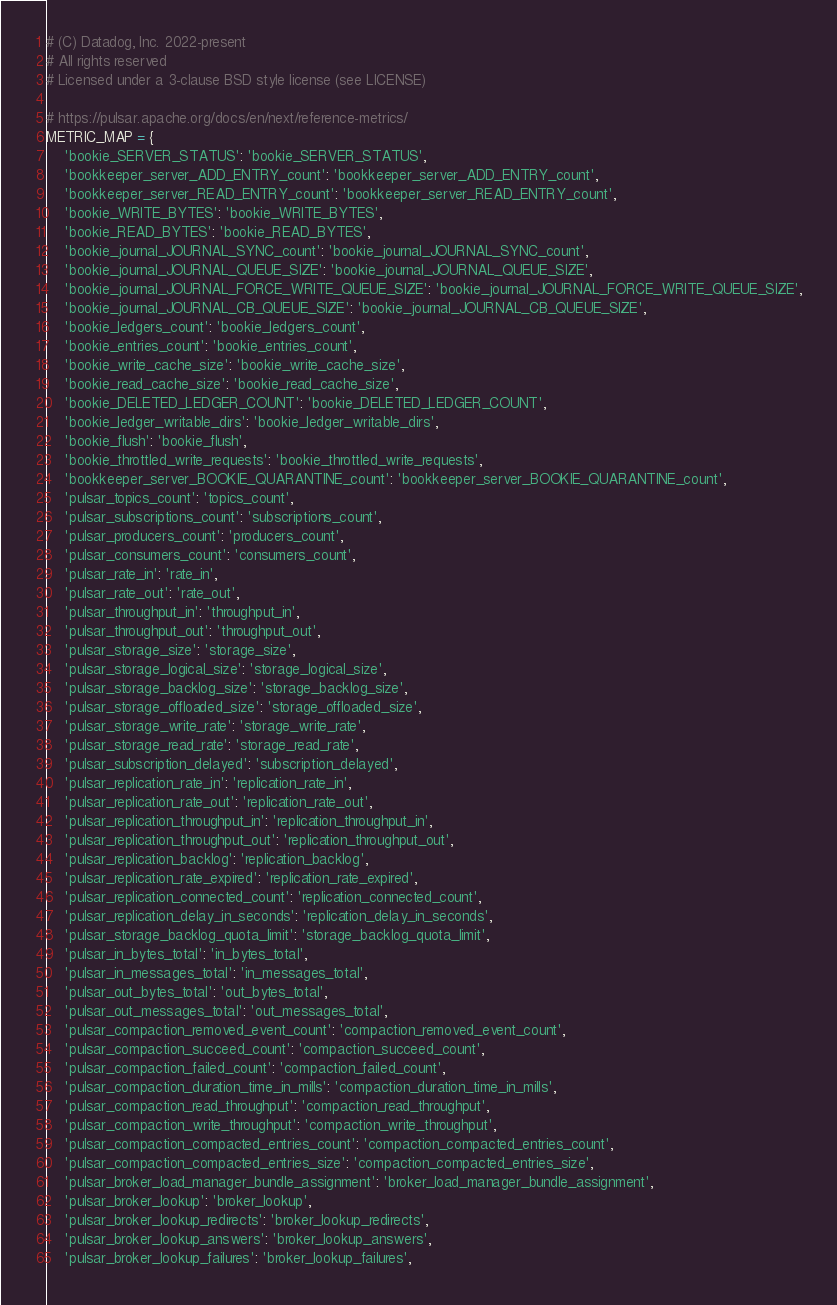<code> <loc_0><loc_0><loc_500><loc_500><_Python_># (C) Datadog, Inc. 2022-present
# All rights reserved
# Licensed under a 3-clause BSD style license (see LICENSE)

# https://pulsar.apache.org/docs/en/next/reference-metrics/
METRIC_MAP = {
    'bookie_SERVER_STATUS': 'bookie_SERVER_STATUS',
    'bookkeeper_server_ADD_ENTRY_count': 'bookkeeper_server_ADD_ENTRY_count',
    'bookkeeper_server_READ_ENTRY_count': 'bookkeeper_server_READ_ENTRY_count',
    'bookie_WRITE_BYTES': 'bookie_WRITE_BYTES',
    'bookie_READ_BYTES': 'bookie_READ_BYTES',
    'bookie_journal_JOURNAL_SYNC_count': 'bookie_journal_JOURNAL_SYNC_count',
    'bookie_journal_JOURNAL_QUEUE_SIZE': 'bookie_journal_JOURNAL_QUEUE_SIZE',
    'bookie_journal_JOURNAL_FORCE_WRITE_QUEUE_SIZE': 'bookie_journal_JOURNAL_FORCE_WRITE_QUEUE_SIZE',
    'bookie_journal_JOURNAL_CB_QUEUE_SIZE': 'bookie_journal_JOURNAL_CB_QUEUE_SIZE',
    'bookie_ledgers_count': 'bookie_ledgers_count',
    'bookie_entries_count': 'bookie_entries_count',
    'bookie_write_cache_size': 'bookie_write_cache_size',
    'bookie_read_cache_size': 'bookie_read_cache_size',
    'bookie_DELETED_LEDGER_COUNT': 'bookie_DELETED_LEDGER_COUNT',
    'bookie_ledger_writable_dirs': 'bookie_ledger_writable_dirs',
    'bookie_flush': 'bookie_flush',
    'bookie_throttled_write_requests': 'bookie_throttled_write_requests',
    'bookkeeper_server_BOOKIE_QUARANTINE_count': 'bookkeeper_server_BOOKIE_QUARANTINE_count',
    'pulsar_topics_count': 'topics_count',
    'pulsar_subscriptions_count': 'subscriptions_count',
    'pulsar_producers_count': 'producers_count',
    'pulsar_consumers_count': 'consumers_count',
    'pulsar_rate_in': 'rate_in',
    'pulsar_rate_out': 'rate_out',
    'pulsar_throughput_in': 'throughput_in',
    'pulsar_throughput_out': 'throughput_out',
    'pulsar_storage_size': 'storage_size',
    'pulsar_storage_logical_size': 'storage_logical_size',
    'pulsar_storage_backlog_size': 'storage_backlog_size',
    'pulsar_storage_offloaded_size': 'storage_offloaded_size',
    'pulsar_storage_write_rate': 'storage_write_rate',
    'pulsar_storage_read_rate': 'storage_read_rate',
    'pulsar_subscription_delayed': 'subscription_delayed',
    'pulsar_replication_rate_in': 'replication_rate_in',
    'pulsar_replication_rate_out': 'replication_rate_out',
    'pulsar_replication_throughput_in': 'replication_throughput_in',
    'pulsar_replication_throughput_out': 'replication_throughput_out',
    'pulsar_replication_backlog': 'replication_backlog',
    'pulsar_replication_rate_expired': 'replication_rate_expired',
    'pulsar_replication_connected_count': 'replication_connected_count',
    'pulsar_replication_delay_in_seconds': 'replication_delay_in_seconds',
    'pulsar_storage_backlog_quota_limit': 'storage_backlog_quota_limit',
    'pulsar_in_bytes_total': 'in_bytes_total',
    'pulsar_in_messages_total': 'in_messages_total',
    'pulsar_out_bytes_total': 'out_bytes_total',
    'pulsar_out_messages_total': 'out_messages_total',
    'pulsar_compaction_removed_event_count': 'compaction_removed_event_count',
    'pulsar_compaction_succeed_count': 'compaction_succeed_count',
    'pulsar_compaction_failed_count': 'compaction_failed_count',
    'pulsar_compaction_duration_time_in_mills': 'compaction_duration_time_in_mills',
    'pulsar_compaction_read_throughput': 'compaction_read_throughput',
    'pulsar_compaction_write_throughput': 'compaction_write_throughput',
    'pulsar_compaction_compacted_entries_count': 'compaction_compacted_entries_count',
    'pulsar_compaction_compacted_entries_size': 'compaction_compacted_entries_size',
    'pulsar_broker_load_manager_bundle_assignment': 'broker_load_manager_bundle_assignment',
    'pulsar_broker_lookup': 'broker_lookup',
    'pulsar_broker_lookup_redirects': 'broker_lookup_redirects',
    'pulsar_broker_lookup_answers': 'broker_lookup_answers',
    'pulsar_broker_lookup_failures': 'broker_lookup_failures',</code> 